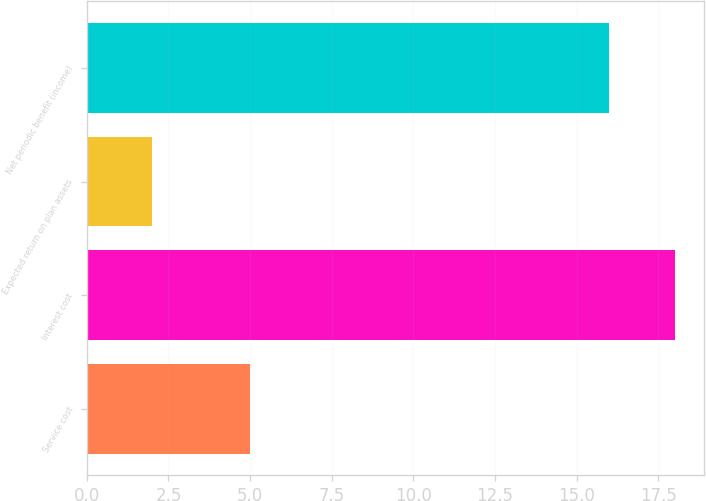Convert chart. <chart><loc_0><loc_0><loc_500><loc_500><bar_chart><fcel>Service cost<fcel>Interest cost<fcel>Expected return on plan assets<fcel>Net periodic benefit (income)<nl><fcel>5<fcel>18<fcel>2<fcel>16<nl></chart> 